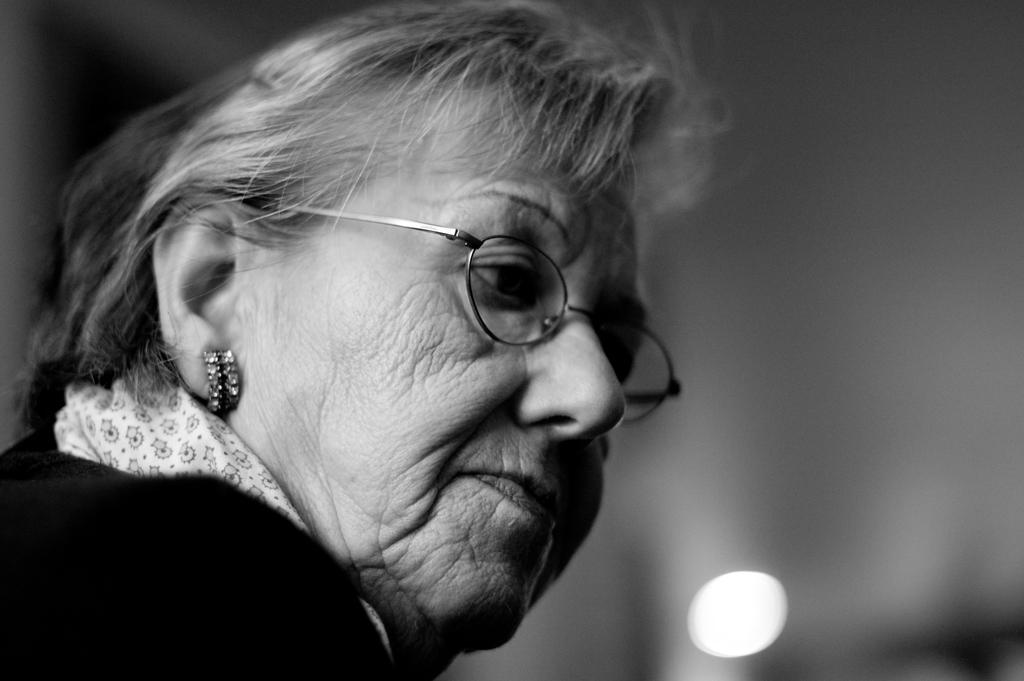What is the color scheme of the image? The image is black and white. Where is the woman located in the image? The woman is on the left side of the image. What is the woman wearing in the image? The woman is wearing spectacles in the image. What is the woman doing in the image? The woman is watching something in the image. What can be seen on the right side of the image? There is light on the right side of the image. How would you describe the background of the image? The background of the image is blurred. What type of cork is being used to seal the parcel in the image? There is no parcel or cork present in the image. 